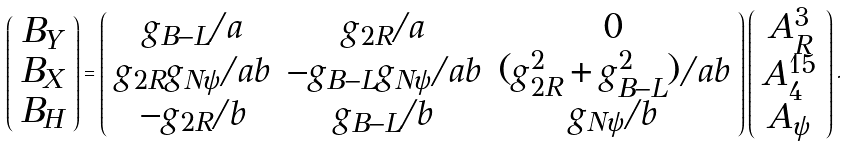Convert formula to latex. <formula><loc_0><loc_0><loc_500><loc_500>\left ( \begin{array} { c } B _ { Y } \\ B _ { X } \\ B _ { H } \end{array} \right ) = \left ( \begin{array} { c c c } g _ { B - L } / a & g _ { 2 R } / a & 0 \\ g _ { 2 R } g _ { N \psi } / a b & - g _ { B - L } g _ { N \psi } / a b & ( g ^ { 2 } _ { 2 R } + g ^ { 2 } _ { B - L } ) / a b \\ - g _ { 2 R } / b & g _ { B - L } / b & g _ { N \psi } / b \end{array} \right ) \left ( \begin{array} { c } A ^ { 3 } _ { R } \\ A ^ { 1 5 } _ { 4 } \\ A _ { \psi } \end{array} \right ) .</formula> 